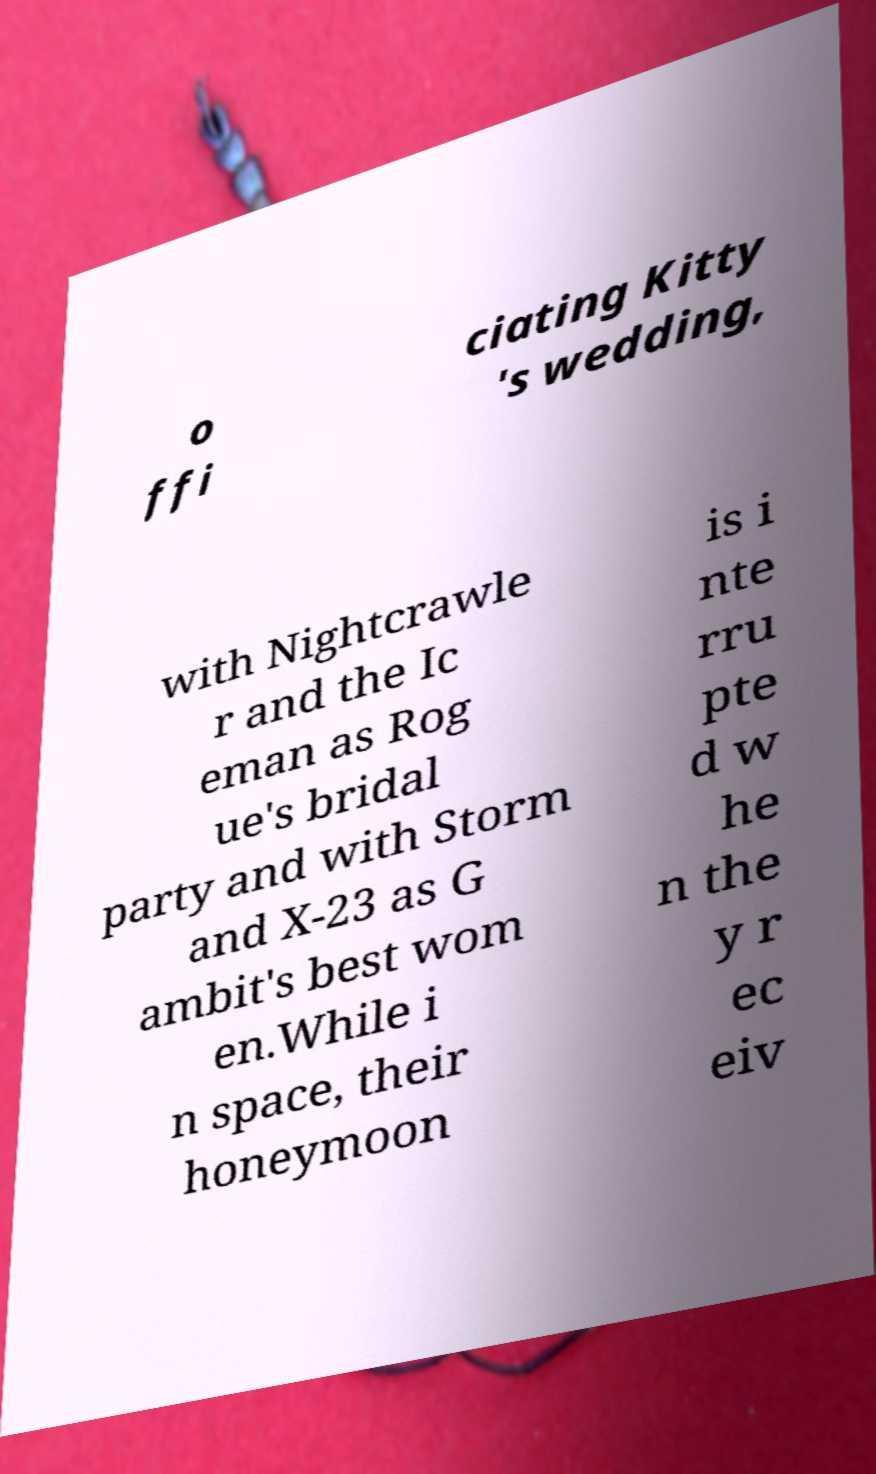Could you extract and type out the text from this image? o ffi ciating Kitty 's wedding, with Nightcrawle r and the Ic eman as Rog ue's bridal party and with Storm and X-23 as G ambit's best wom en.While i n space, their honeymoon is i nte rru pte d w he n the y r ec eiv 